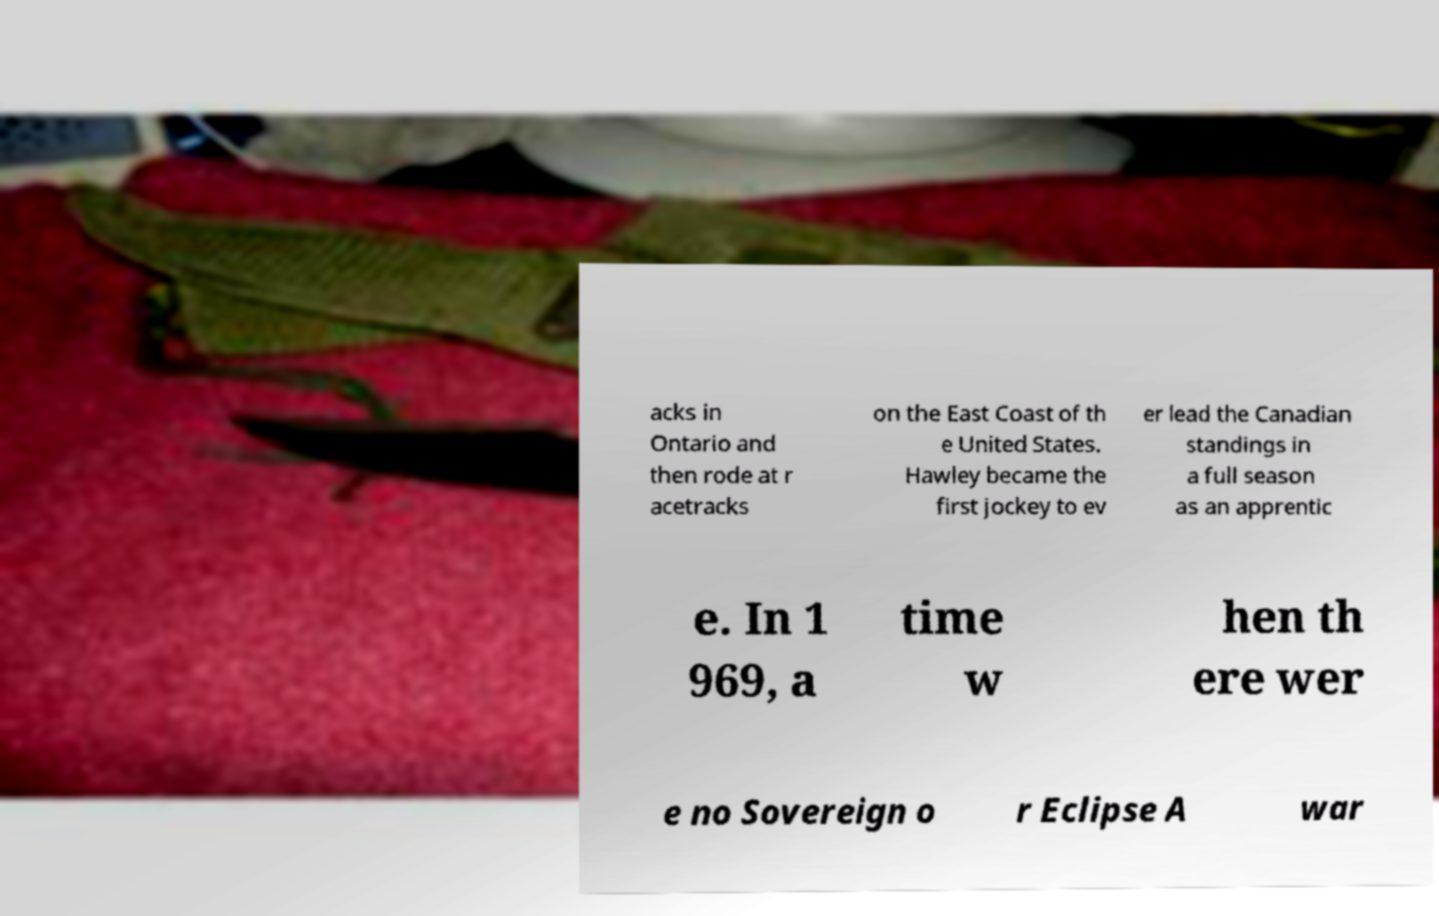Can you accurately transcribe the text from the provided image for me? acks in Ontario and then rode at r acetracks on the East Coast of th e United States. Hawley became the first jockey to ev er lead the Canadian standings in a full season as an apprentic e. In 1 969, a time w hen th ere wer e no Sovereign o r Eclipse A war 